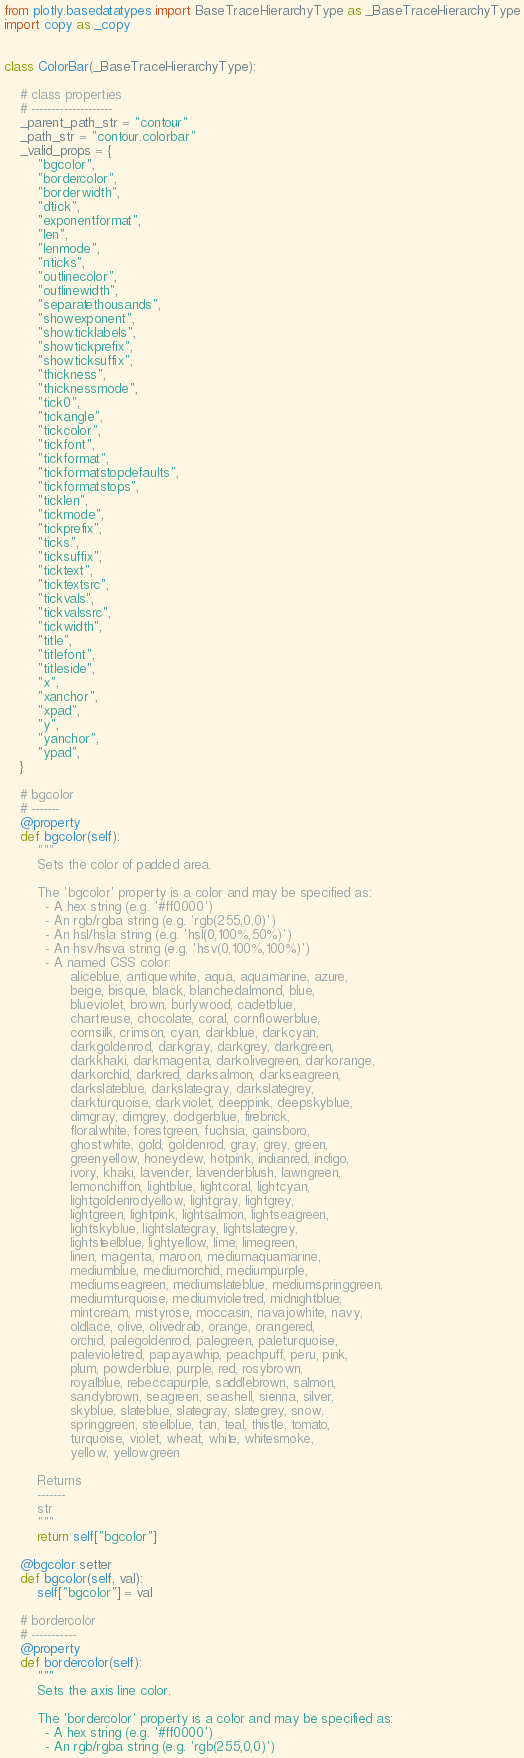<code> <loc_0><loc_0><loc_500><loc_500><_Python_>from plotly.basedatatypes import BaseTraceHierarchyType as _BaseTraceHierarchyType
import copy as _copy


class ColorBar(_BaseTraceHierarchyType):

    # class properties
    # --------------------
    _parent_path_str = "contour"
    _path_str = "contour.colorbar"
    _valid_props = {
        "bgcolor",
        "bordercolor",
        "borderwidth",
        "dtick",
        "exponentformat",
        "len",
        "lenmode",
        "nticks",
        "outlinecolor",
        "outlinewidth",
        "separatethousands",
        "showexponent",
        "showticklabels",
        "showtickprefix",
        "showticksuffix",
        "thickness",
        "thicknessmode",
        "tick0",
        "tickangle",
        "tickcolor",
        "tickfont",
        "tickformat",
        "tickformatstopdefaults",
        "tickformatstops",
        "ticklen",
        "tickmode",
        "tickprefix",
        "ticks",
        "ticksuffix",
        "ticktext",
        "ticktextsrc",
        "tickvals",
        "tickvalssrc",
        "tickwidth",
        "title",
        "titlefont",
        "titleside",
        "x",
        "xanchor",
        "xpad",
        "y",
        "yanchor",
        "ypad",
    }

    # bgcolor
    # -------
    @property
    def bgcolor(self):
        """
        Sets the color of padded area.
    
        The 'bgcolor' property is a color and may be specified as:
          - A hex string (e.g. '#ff0000')
          - An rgb/rgba string (e.g. 'rgb(255,0,0)')
          - An hsl/hsla string (e.g. 'hsl(0,100%,50%)')
          - An hsv/hsva string (e.g. 'hsv(0,100%,100%)')
          - A named CSS color:
                aliceblue, antiquewhite, aqua, aquamarine, azure,
                beige, bisque, black, blanchedalmond, blue,
                blueviolet, brown, burlywood, cadetblue,
                chartreuse, chocolate, coral, cornflowerblue,
                cornsilk, crimson, cyan, darkblue, darkcyan,
                darkgoldenrod, darkgray, darkgrey, darkgreen,
                darkkhaki, darkmagenta, darkolivegreen, darkorange,
                darkorchid, darkred, darksalmon, darkseagreen,
                darkslateblue, darkslategray, darkslategrey,
                darkturquoise, darkviolet, deeppink, deepskyblue,
                dimgray, dimgrey, dodgerblue, firebrick,
                floralwhite, forestgreen, fuchsia, gainsboro,
                ghostwhite, gold, goldenrod, gray, grey, green,
                greenyellow, honeydew, hotpink, indianred, indigo,
                ivory, khaki, lavender, lavenderblush, lawngreen,
                lemonchiffon, lightblue, lightcoral, lightcyan,
                lightgoldenrodyellow, lightgray, lightgrey,
                lightgreen, lightpink, lightsalmon, lightseagreen,
                lightskyblue, lightslategray, lightslategrey,
                lightsteelblue, lightyellow, lime, limegreen,
                linen, magenta, maroon, mediumaquamarine,
                mediumblue, mediumorchid, mediumpurple,
                mediumseagreen, mediumslateblue, mediumspringgreen,
                mediumturquoise, mediumvioletred, midnightblue,
                mintcream, mistyrose, moccasin, navajowhite, navy,
                oldlace, olive, olivedrab, orange, orangered,
                orchid, palegoldenrod, palegreen, paleturquoise,
                palevioletred, papayawhip, peachpuff, peru, pink,
                plum, powderblue, purple, red, rosybrown,
                royalblue, rebeccapurple, saddlebrown, salmon,
                sandybrown, seagreen, seashell, sienna, silver,
                skyblue, slateblue, slategray, slategrey, snow,
                springgreen, steelblue, tan, teal, thistle, tomato,
                turquoise, violet, wheat, white, whitesmoke,
                yellow, yellowgreen

        Returns
        -------
        str
        """
        return self["bgcolor"]

    @bgcolor.setter
    def bgcolor(self, val):
        self["bgcolor"] = val

    # bordercolor
    # -----------
    @property
    def bordercolor(self):
        """
        Sets the axis line color.
    
        The 'bordercolor' property is a color and may be specified as:
          - A hex string (e.g. '#ff0000')
          - An rgb/rgba string (e.g. 'rgb(255,0,0)')</code> 